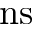<formula> <loc_0><loc_0><loc_500><loc_500>n s</formula> 